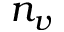Convert formula to latex. <formula><loc_0><loc_0><loc_500><loc_500>n _ { v }</formula> 